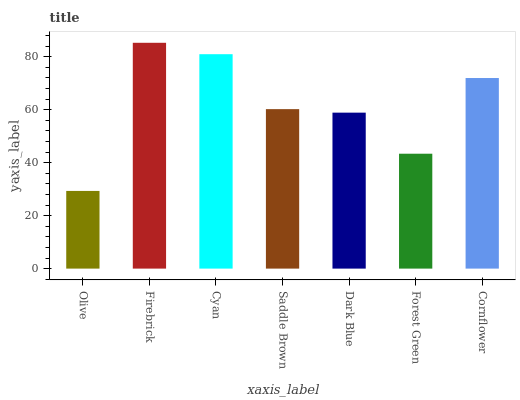Is Olive the minimum?
Answer yes or no. Yes. Is Firebrick the maximum?
Answer yes or no. Yes. Is Cyan the minimum?
Answer yes or no. No. Is Cyan the maximum?
Answer yes or no. No. Is Firebrick greater than Cyan?
Answer yes or no. Yes. Is Cyan less than Firebrick?
Answer yes or no. Yes. Is Cyan greater than Firebrick?
Answer yes or no. No. Is Firebrick less than Cyan?
Answer yes or no. No. Is Saddle Brown the high median?
Answer yes or no. Yes. Is Saddle Brown the low median?
Answer yes or no. Yes. Is Dark Blue the high median?
Answer yes or no. No. Is Dark Blue the low median?
Answer yes or no. No. 